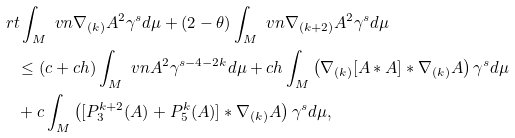<formula> <loc_0><loc_0><loc_500><loc_500>& \ r { t } \int _ { M } \ v n { \nabla _ { ( k ) } A } ^ { 2 } \gamma ^ { s } d \mu + ( 2 - \theta ) \int _ { M } \ v n { \nabla _ { ( k + 2 ) } A } ^ { 2 } \gamma ^ { s } d \mu \\ & \quad \leq ( c + c h ) \int _ { M } \ v n { A } ^ { 2 } \gamma ^ { s - 4 - 2 k } d \mu + c h \int _ { M } \left ( \nabla _ { ( k ) } [ A * A ] * \nabla _ { ( k ) } A \right ) \gamma ^ { s } d \mu \\ & \quad + c \int _ { M } \left ( [ P _ { 3 } ^ { k + 2 } ( A ) + P _ { 5 } ^ { k } ( A ) ] * \nabla _ { ( k ) } A \right ) \gamma ^ { s } d \mu ,</formula> 